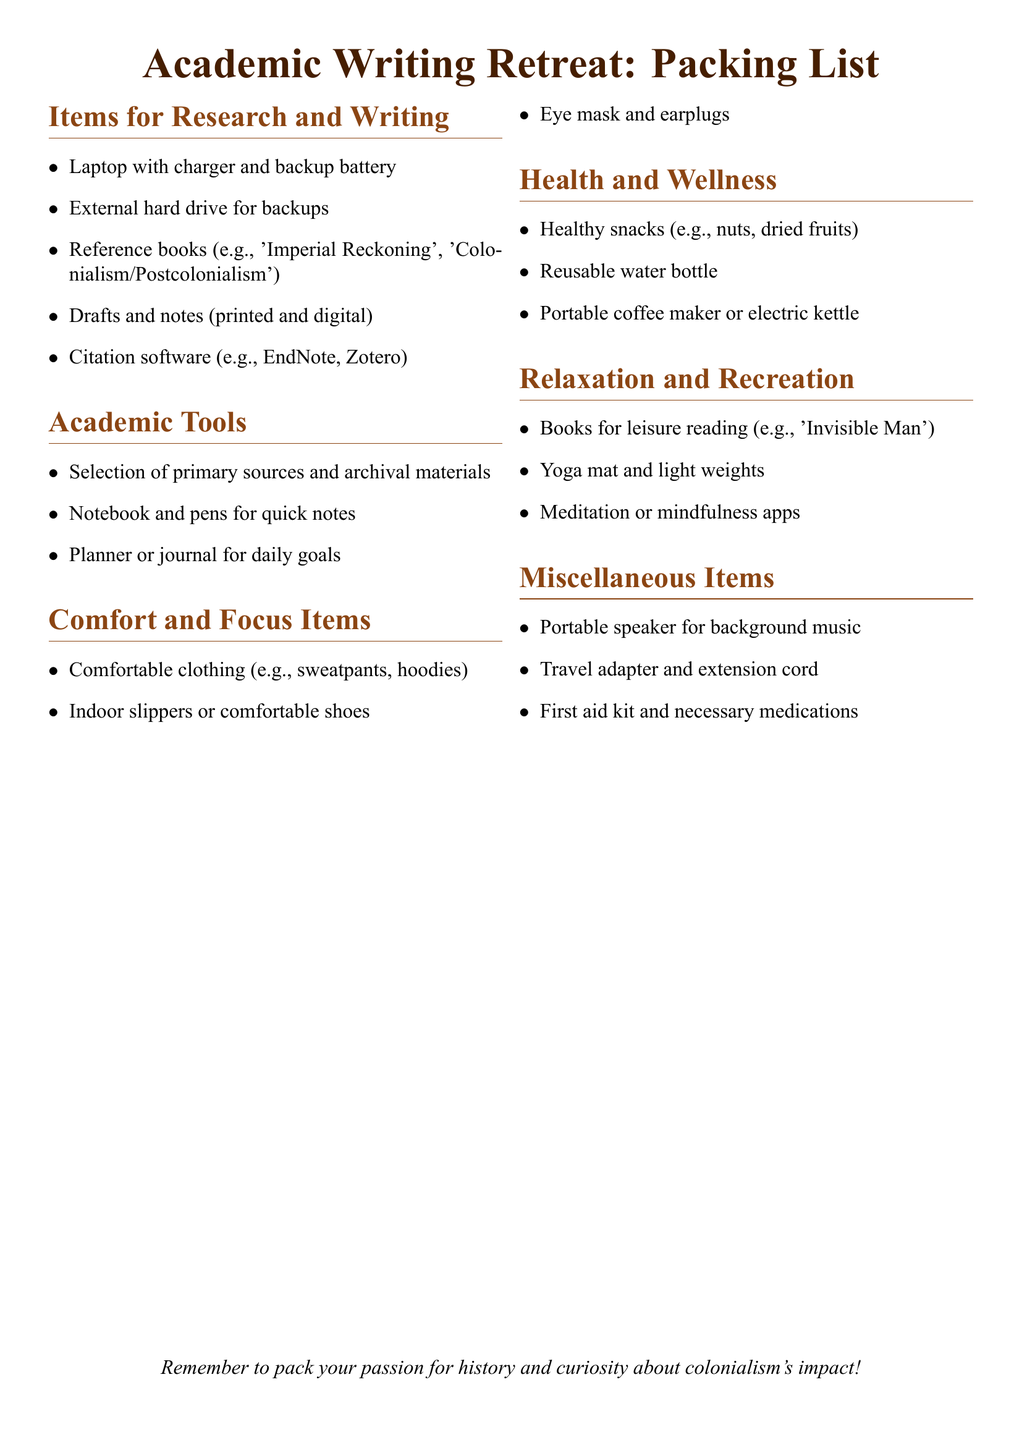What types of books are suggested for reference? The document lists examples of reference books relevant to the academic writing retreat, focusing on colonial themes.
Answer: 'Imperial Reckoning', 'Colonialism/Postcolonialism' Which citation software is mentioned? The packing list includes a specific type of software that assists in organizing citations for academic writing.
Answer: EndNote, Zotero What clothing items are recommended for comfort? The document highlights specific articles of clothing that contribute to comfort during the retreat.
Answer: Sweatpants, hoodies What health item is suggested to stay hydrated? The packing list specifies a reusable item that is important for maintaining hydration during the retreat.
Answer: Reusable water bottle How many sections are there in the packing list? To understand the structure of the document, one counts the distinct categories of items outlined in the list.
Answer: Six 